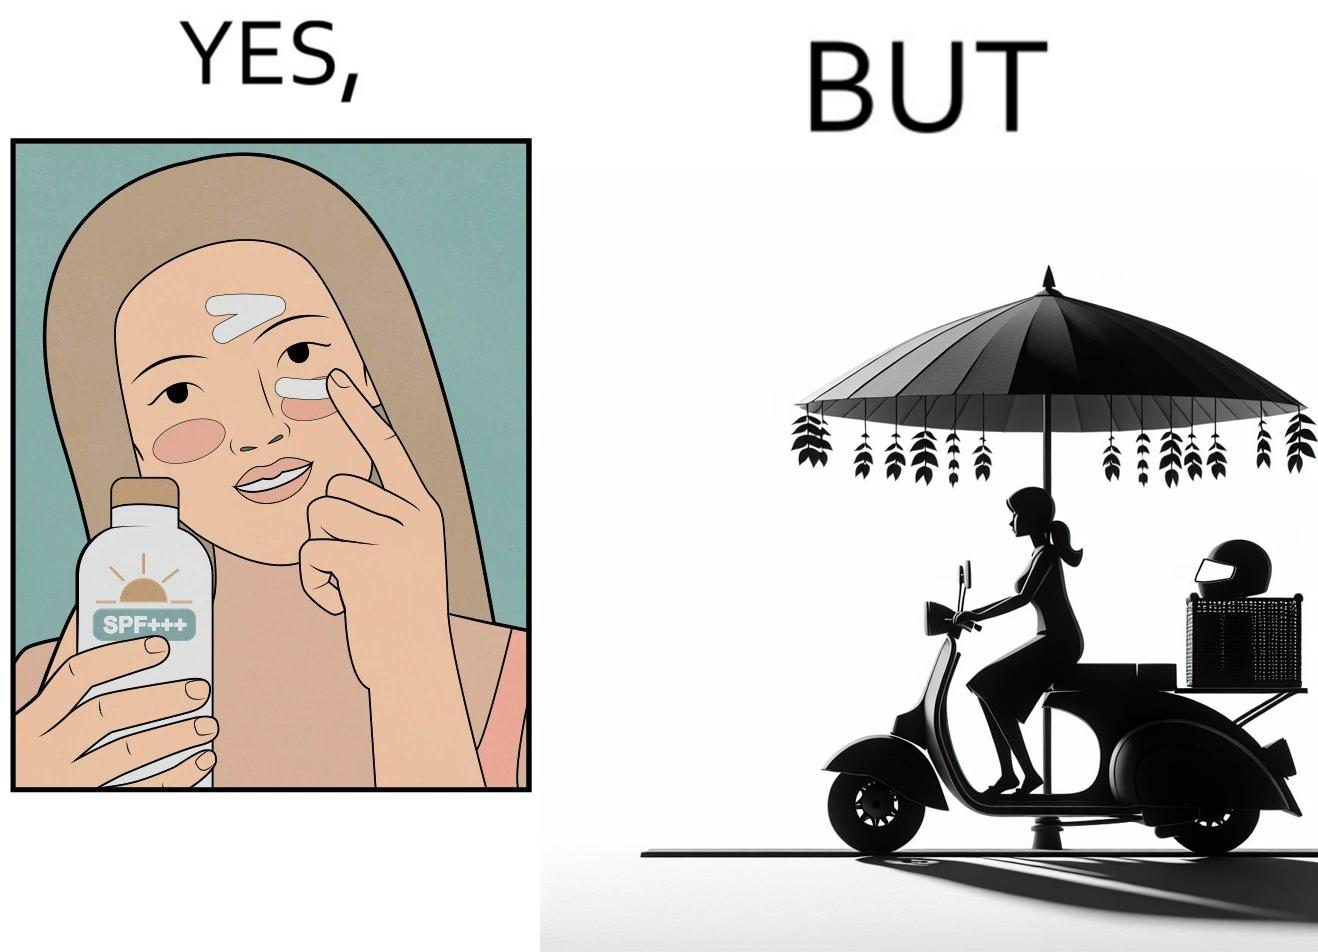Describe the contrast between the left and right parts of this image. In the left part of the image: The image shows a woman applying sunscreen with high SPF on her face. In the right part of the image: The image shows a woman riding a scooter with her helmet on the back seat. 